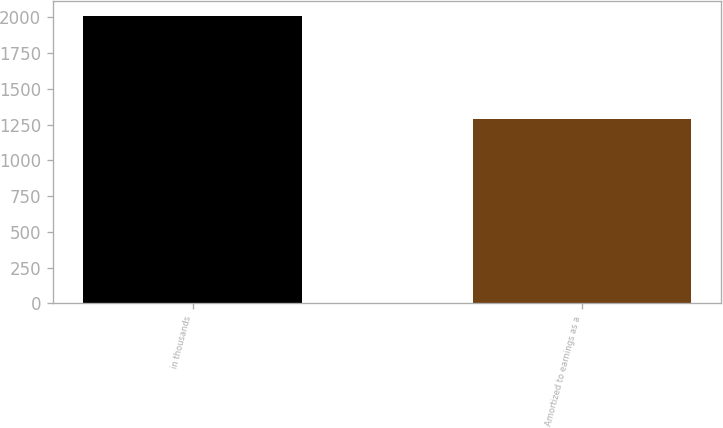<chart> <loc_0><loc_0><loc_500><loc_500><bar_chart><fcel>in thousands<fcel>Amortized to earnings as a<nl><fcel>2011<fcel>1291<nl></chart> 